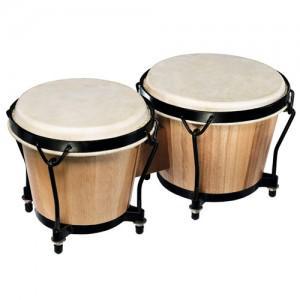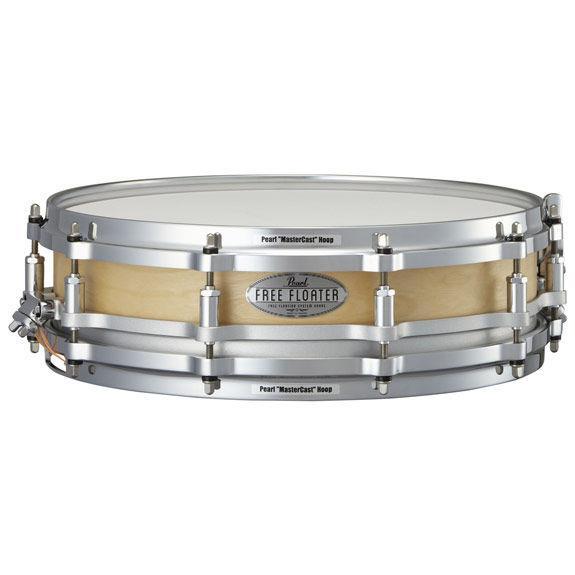The first image is the image on the left, the second image is the image on the right. For the images shown, is this caption "Each image shows a connected pair of drums, and one image features wood grain drums without a footed stand." true? Answer yes or no. No. The first image is the image on the left, the second image is the image on the right. Assess this claim about the two images: "There are exactly two pairs of bongo drums.". Correct or not? Answer yes or no. No. 